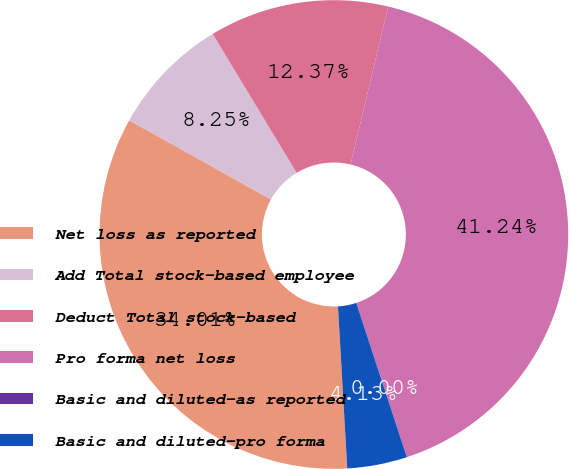Convert chart to OTSL. <chart><loc_0><loc_0><loc_500><loc_500><pie_chart><fcel>Net loss as reported<fcel>Add Total stock-based employee<fcel>Deduct Total stock-based<fcel>Pro forma net loss<fcel>Basic and diluted-as reported<fcel>Basic and diluted-pro forma<nl><fcel>34.01%<fcel>8.25%<fcel>12.37%<fcel>41.24%<fcel>0.0%<fcel>4.13%<nl></chart> 